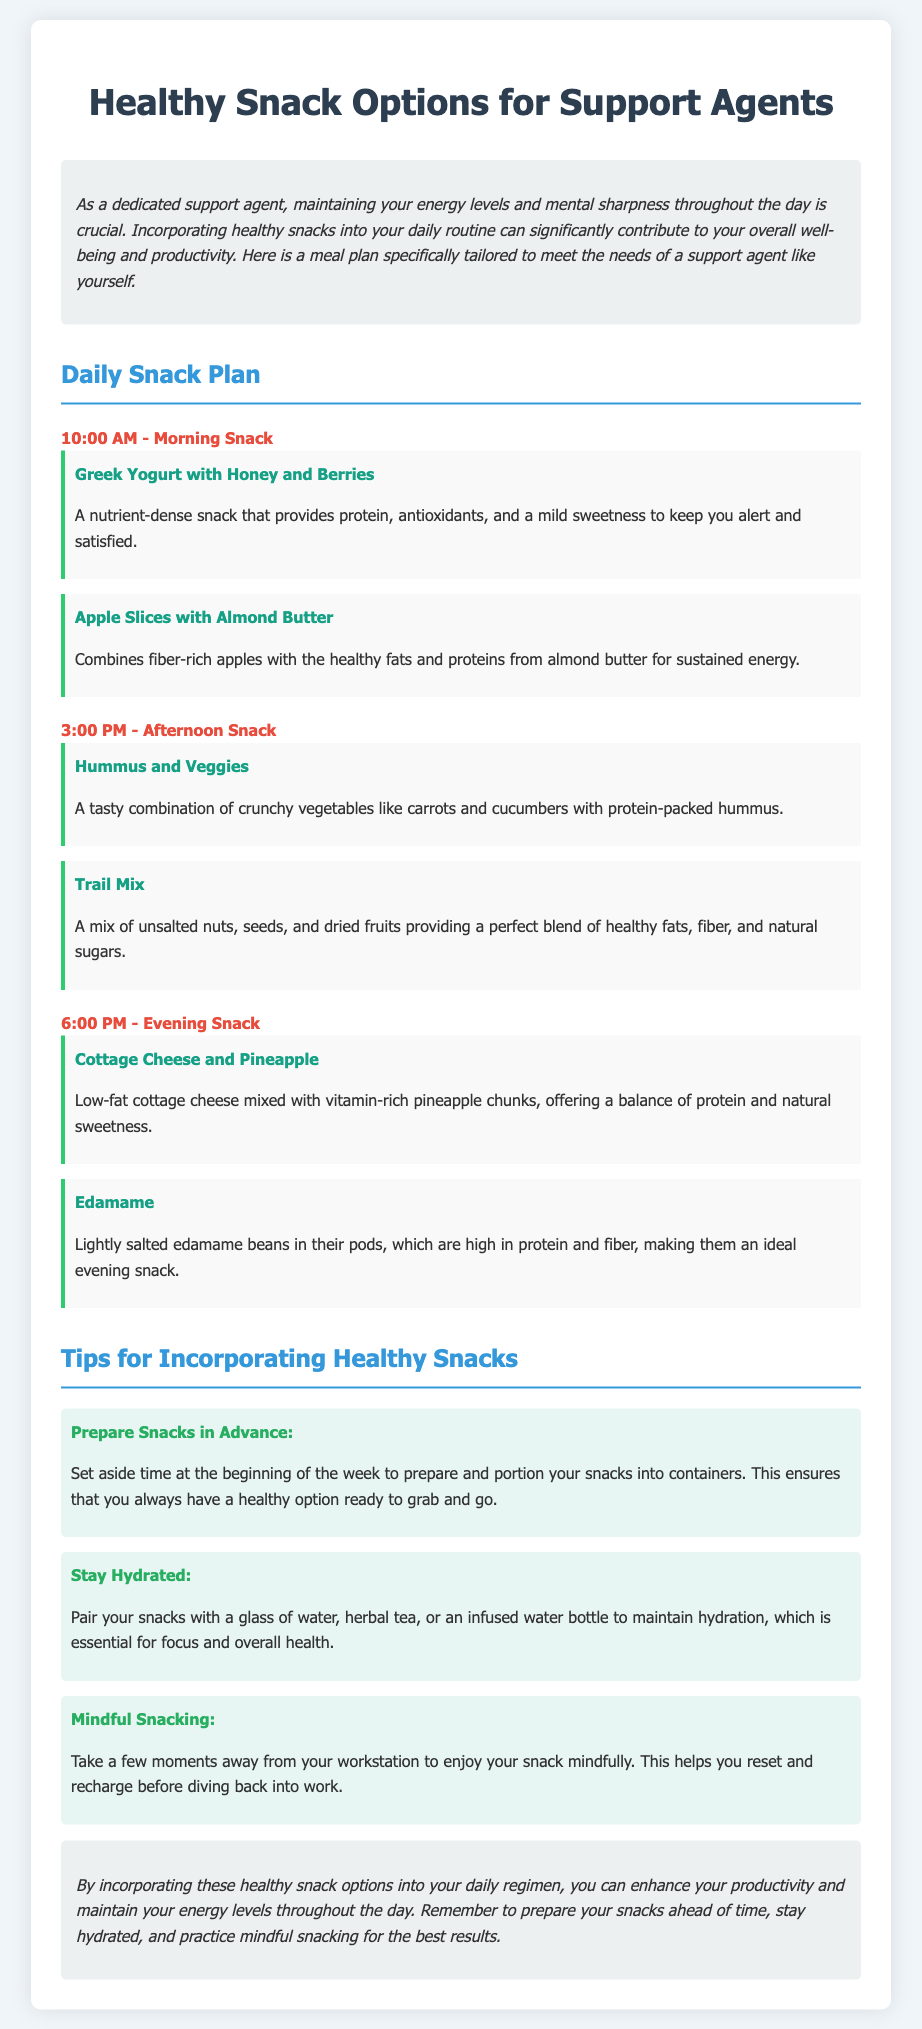what is the time for the morning snack? The document states the morning snack is scheduled for 10:00 AM.
Answer: 10:00 AM what snack includes Greek yogurt? The snack with Greek yogurt is "Greek Yogurt with Honey and Berries."
Answer: Greek Yogurt with Honey and Berries what is recommended to pair with snacks for hydration? The document suggests pairing snacks with a glass of water, herbal tea, or an infused water bottle.
Answer: A glass of water how many snacks are listed for the afternoon? There are two snacks listed for the afternoon.
Answer: Two what is one benefit of mindful snacking? Mindful snacking helps you reset and recharge before diving back into work.
Answer: Reset and recharge which snack item comes with protein-packed hummus? The snack that comes with protein-packed hummus is "Hummus and Veggies."
Answer: Hummus and Veggies what fruit is mixed with cottage cheese in the evening snack? The fruit mixed with cottage cheese is pineapple.
Answer: Pineapple what is a tip for preparing snacks? One tip is to prepare and portion your snacks into containers at the beginning of the week.
Answer: Prepare snacks in advance at what time is the evening snack scheduled? The evening snack is scheduled for 6:00 PM.
Answer: 6:00 PM 